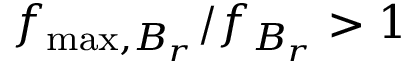<formula> <loc_0><loc_0><loc_500><loc_500>f _ { \max , B _ { r } } / f _ { B _ { r } } > 1</formula> 